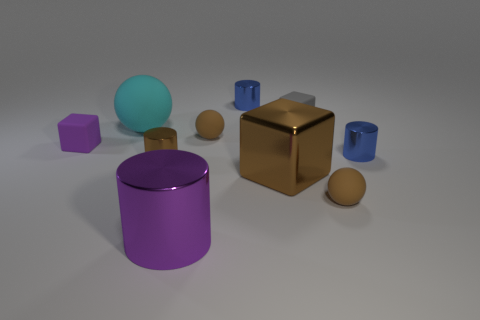Subtract all red cylinders. How many brown spheres are left? 2 Subtract all small cubes. How many cubes are left? 1 Subtract 1 cubes. How many cubes are left? 2 Subtract all purple cylinders. How many cylinders are left? 3 Subtract all yellow blocks. Subtract all green spheres. How many blocks are left? 3 Subtract all cylinders. How many objects are left? 6 Subtract 0 yellow balls. How many objects are left? 10 Subtract all big purple cylinders. Subtract all big brown metallic cubes. How many objects are left? 8 Add 5 big purple cylinders. How many big purple cylinders are left? 6 Add 4 tiny metal things. How many tiny metal things exist? 7 